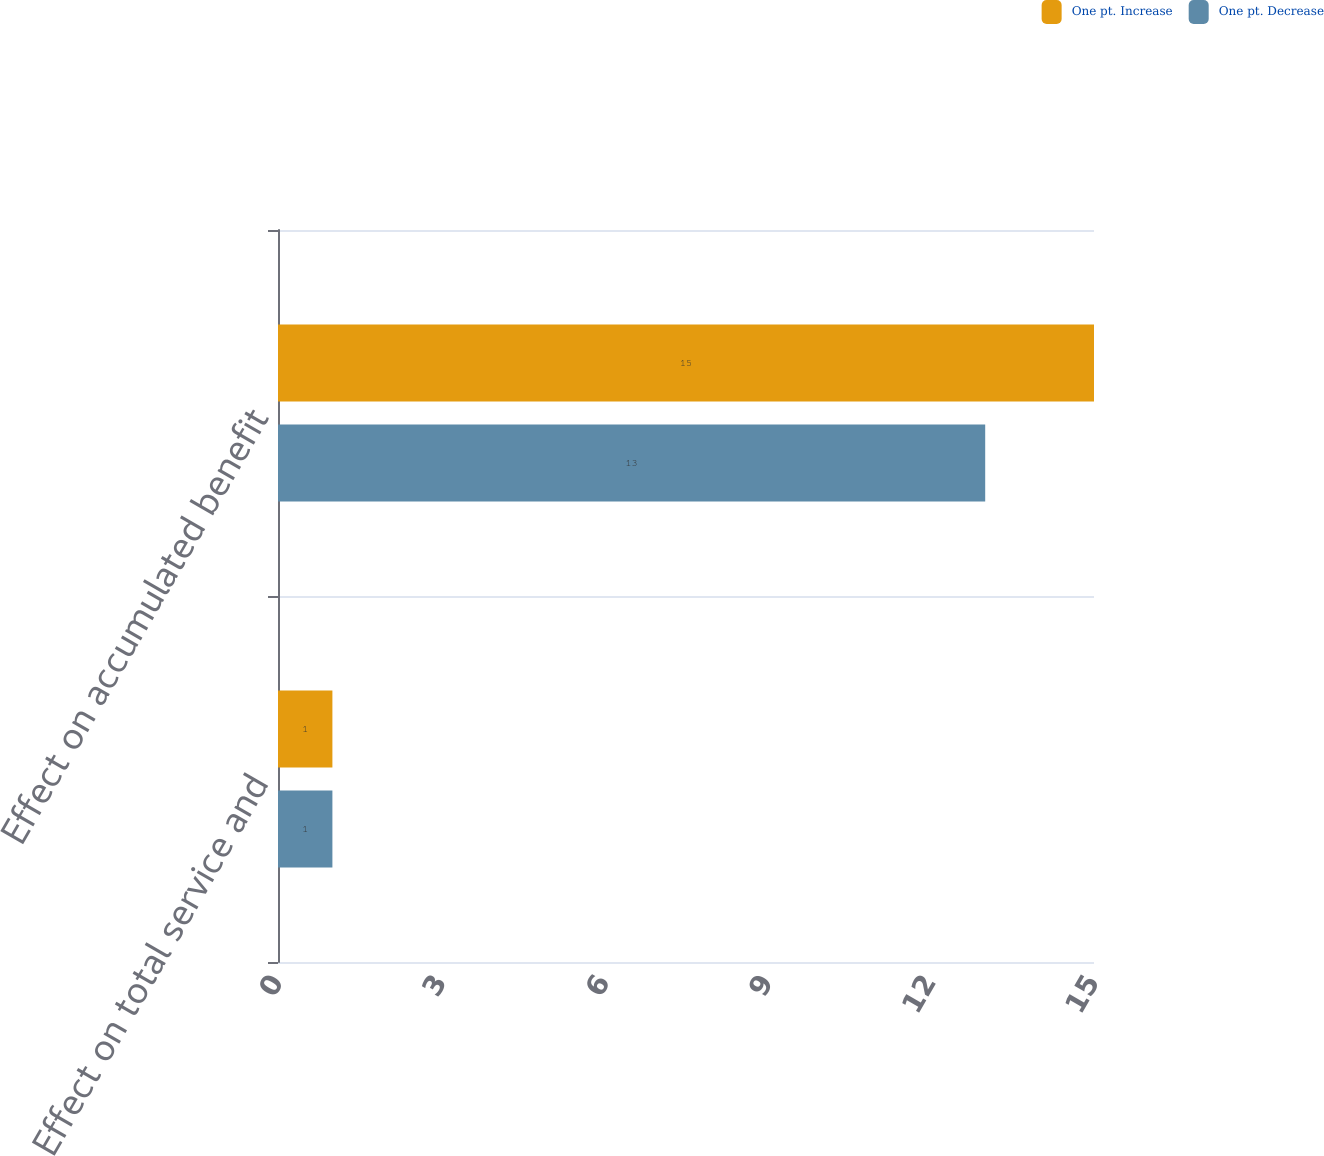Convert chart. <chart><loc_0><loc_0><loc_500><loc_500><stacked_bar_chart><ecel><fcel>Effect on total service and<fcel>Effect on accumulated benefit<nl><fcel>One pt. Increase<fcel>1<fcel>15<nl><fcel>One pt. Decrease<fcel>1<fcel>13<nl></chart> 